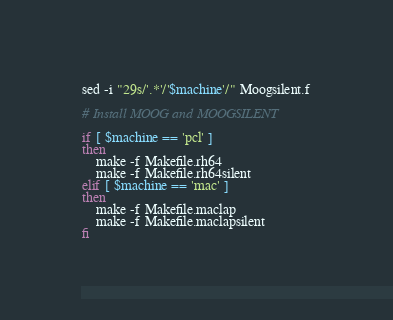<code> <loc_0><loc_0><loc_500><loc_500><_Bash_>sed -i "29s/'.*'/'$machine'/" Moogsilent.f

# Install MOOG and MOOGSILENT

if [ $machine == 'pcl' ]
then
	make -f Makefile.rh64 
	make -f Makefile.rh64silent 
elif [ $machine == 'mac' ]
then
	make -f Makefile.maclap 
	make -f Makefile.maclapsilent 
fi
</code> 